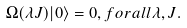<formula> <loc_0><loc_0><loc_500><loc_500>\Omega ( \lambda J ) | 0 \rangle = 0 , f o r a l l \lambda , J .</formula> 